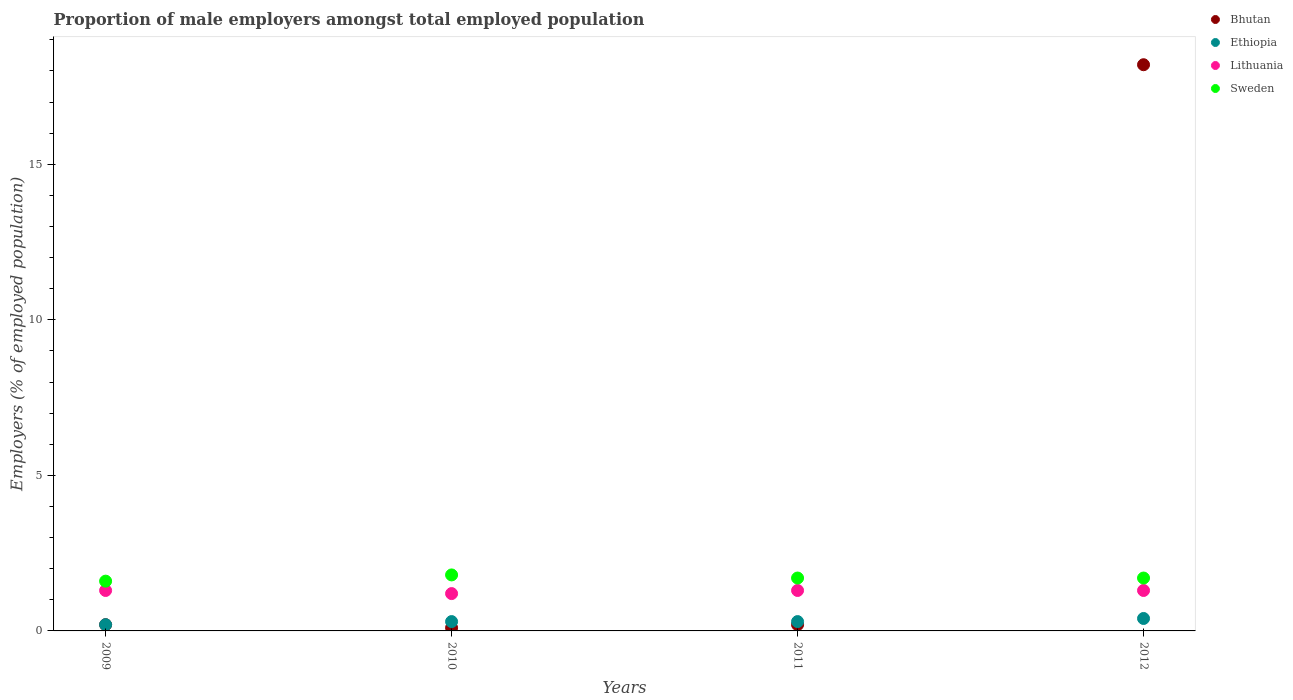How many different coloured dotlines are there?
Provide a succinct answer. 4. Is the number of dotlines equal to the number of legend labels?
Your response must be concise. Yes. What is the proportion of male employers in Ethiopia in 2011?
Ensure brevity in your answer.  0.3. Across all years, what is the maximum proportion of male employers in Ethiopia?
Your answer should be compact. 0.4. Across all years, what is the minimum proportion of male employers in Ethiopia?
Your answer should be very brief. 0.2. In which year was the proportion of male employers in Ethiopia maximum?
Make the answer very short. 2012. In which year was the proportion of male employers in Bhutan minimum?
Ensure brevity in your answer.  2010. What is the total proportion of male employers in Sweden in the graph?
Your answer should be compact. 6.8. What is the difference between the proportion of male employers in Bhutan in 2011 and that in 2012?
Offer a terse response. -18. What is the difference between the proportion of male employers in Lithuania in 2009 and the proportion of male employers in Bhutan in 2012?
Ensure brevity in your answer.  -16.9. What is the average proportion of male employers in Bhutan per year?
Your answer should be compact. 4.68. In the year 2011, what is the difference between the proportion of male employers in Ethiopia and proportion of male employers in Lithuania?
Your answer should be compact. -1. What is the ratio of the proportion of male employers in Bhutan in 2009 to that in 2012?
Make the answer very short. 0.01. Is the difference between the proportion of male employers in Ethiopia in 2009 and 2012 greater than the difference between the proportion of male employers in Lithuania in 2009 and 2012?
Ensure brevity in your answer.  No. What is the difference between the highest and the lowest proportion of male employers in Ethiopia?
Provide a short and direct response. 0.2. In how many years, is the proportion of male employers in Sweden greater than the average proportion of male employers in Sweden taken over all years?
Keep it short and to the point. 3. Is it the case that in every year, the sum of the proportion of male employers in Sweden and proportion of male employers in Lithuania  is greater than the sum of proportion of male employers in Bhutan and proportion of male employers in Ethiopia?
Make the answer very short. Yes. Is it the case that in every year, the sum of the proportion of male employers in Lithuania and proportion of male employers in Ethiopia  is greater than the proportion of male employers in Sweden?
Offer a terse response. No. How many dotlines are there?
Offer a very short reply. 4. What is the difference between two consecutive major ticks on the Y-axis?
Offer a terse response. 5. Are the values on the major ticks of Y-axis written in scientific E-notation?
Provide a succinct answer. No. Does the graph contain any zero values?
Offer a terse response. No. How many legend labels are there?
Provide a succinct answer. 4. What is the title of the graph?
Ensure brevity in your answer.  Proportion of male employers amongst total employed population. Does "Lebanon" appear as one of the legend labels in the graph?
Offer a very short reply. No. What is the label or title of the Y-axis?
Your answer should be very brief. Employers (% of employed population). What is the Employers (% of employed population) of Bhutan in 2009?
Offer a very short reply. 0.2. What is the Employers (% of employed population) in Ethiopia in 2009?
Keep it short and to the point. 0.2. What is the Employers (% of employed population) in Lithuania in 2009?
Give a very brief answer. 1.3. What is the Employers (% of employed population) in Sweden in 2009?
Provide a succinct answer. 1.6. What is the Employers (% of employed population) in Bhutan in 2010?
Your answer should be very brief. 0.1. What is the Employers (% of employed population) of Ethiopia in 2010?
Give a very brief answer. 0.3. What is the Employers (% of employed population) of Lithuania in 2010?
Offer a terse response. 1.2. What is the Employers (% of employed population) of Sweden in 2010?
Offer a very short reply. 1.8. What is the Employers (% of employed population) in Bhutan in 2011?
Provide a short and direct response. 0.2. What is the Employers (% of employed population) of Ethiopia in 2011?
Give a very brief answer. 0.3. What is the Employers (% of employed population) of Lithuania in 2011?
Keep it short and to the point. 1.3. What is the Employers (% of employed population) in Sweden in 2011?
Make the answer very short. 1.7. What is the Employers (% of employed population) of Bhutan in 2012?
Ensure brevity in your answer.  18.2. What is the Employers (% of employed population) of Ethiopia in 2012?
Your response must be concise. 0.4. What is the Employers (% of employed population) of Lithuania in 2012?
Ensure brevity in your answer.  1.3. What is the Employers (% of employed population) in Sweden in 2012?
Your answer should be very brief. 1.7. Across all years, what is the maximum Employers (% of employed population) of Bhutan?
Keep it short and to the point. 18.2. Across all years, what is the maximum Employers (% of employed population) of Ethiopia?
Your answer should be very brief. 0.4. Across all years, what is the maximum Employers (% of employed population) of Lithuania?
Give a very brief answer. 1.3. Across all years, what is the maximum Employers (% of employed population) in Sweden?
Offer a very short reply. 1.8. Across all years, what is the minimum Employers (% of employed population) in Bhutan?
Your answer should be compact. 0.1. Across all years, what is the minimum Employers (% of employed population) of Ethiopia?
Make the answer very short. 0.2. Across all years, what is the minimum Employers (% of employed population) of Lithuania?
Your answer should be very brief. 1.2. Across all years, what is the minimum Employers (% of employed population) in Sweden?
Ensure brevity in your answer.  1.6. What is the total Employers (% of employed population) in Bhutan in the graph?
Offer a terse response. 18.7. What is the difference between the Employers (% of employed population) of Ethiopia in 2009 and that in 2010?
Offer a terse response. -0.1. What is the difference between the Employers (% of employed population) in Sweden in 2009 and that in 2010?
Your response must be concise. -0.2. What is the difference between the Employers (% of employed population) of Bhutan in 2009 and that in 2011?
Your response must be concise. 0. What is the difference between the Employers (% of employed population) in Ethiopia in 2009 and that in 2012?
Offer a terse response. -0.2. What is the difference between the Employers (% of employed population) of Lithuania in 2009 and that in 2012?
Offer a terse response. 0. What is the difference between the Employers (% of employed population) in Bhutan in 2010 and that in 2011?
Provide a short and direct response. -0.1. What is the difference between the Employers (% of employed population) in Sweden in 2010 and that in 2011?
Ensure brevity in your answer.  0.1. What is the difference between the Employers (% of employed population) of Bhutan in 2010 and that in 2012?
Provide a short and direct response. -18.1. What is the difference between the Employers (% of employed population) of Ethiopia in 2010 and that in 2012?
Ensure brevity in your answer.  -0.1. What is the difference between the Employers (% of employed population) in Lithuania in 2010 and that in 2012?
Make the answer very short. -0.1. What is the difference between the Employers (% of employed population) in Ethiopia in 2011 and that in 2012?
Make the answer very short. -0.1. What is the difference between the Employers (% of employed population) of Sweden in 2011 and that in 2012?
Ensure brevity in your answer.  0. What is the difference between the Employers (% of employed population) in Bhutan in 2009 and the Employers (% of employed population) in Ethiopia in 2010?
Your response must be concise. -0.1. What is the difference between the Employers (% of employed population) in Ethiopia in 2009 and the Employers (% of employed population) in Sweden in 2010?
Your response must be concise. -1.6. What is the difference between the Employers (% of employed population) in Bhutan in 2009 and the Employers (% of employed population) in Sweden in 2011?
Provide a succinct answer. -1.5. What is the difference between the Employers (% of employed population) in Lithuania in 2009 and the Employers (% of employed population) in Sweden in 2011?
Your response must be concise. -0.4. What is the difference between the Employers (% of employed population) in Bhutan in 2009 and the Employers (% of employed population) in Sweden in 2012?
Your answer should be very brief. -1.5. What is the difference between the Employers (% of employed population) of Ethiopia in 2009 and the Employers (% of employed population) of Lithuania in 2012?
Your answer should be compact. -1.1. What is the difference between the Employers (% of employed population) in Ethiopia in 2009 and the Employers (% of employed population) in Sweden in 2012?
Offer a very short reply. -1.5. What is the difference between the Employers (% of employed population) of Bhutan in 2010 and the Employers (% of employed population) of Ethiopia in 2011?
Offer a very short reply. -0.2. What is the difference between the Employers (% of employed population) of Bhutan in 2010 and the Employers (% of employed population) of Sweden in 2011?
Offer a terse response. -1.6. What is the difference between the Employers (% of employed population) of Ethiopia in 2010 and the Employers (% of employed population) of Sweden in 2011?
Provide a succinct answer. -1.4. What is the difference between the Employers (% of employed population) in Lithuania in 2010 and the Employers (% of employed population) in Sweden in 2011?
Give a very brief answer. -0.5. What is the difference between the Employers (% of employed population) of Bhutan in 2010 and the Employers (% of employed population) of Ethiopia in 2012?
Offer a very short reply. -0.3. What is the difference between the Employers (% of employed population) in Bhutan in 2010 and the Employers (% of employed population) in Lithuania in 2012?
Offer a terse response. -1.2. What is the difference between the Employers (% of employed population) of Bhutan in 2010 and the Employers (% of employed population) of Sweden in 2012?
Ensure brevity in your answer.  -1.6. What is the difference between the Employers (% of employed population) in Ethiopia in 2010 and the Employers (% of employed population) in Sweden in 2012?
Keep it short and to the point. -1.4. What is the difference between the Employers (% of employed population) of Lithuania in 2010 and the Employers (% of employed population) of Sweden in 2012?
Give a very brief answer. -0.5. What is the difference between the Employers (% of employed population) of Bhutan in 2011 and the Employers (% of employed population) of Ethiopia in 2012?
Give a very brief answer. -0.2. What is the difference between the Employers (% of employed population) of Bhutan in 2011 and the Employers (% of employed population) of Lithuania in 2012?
Provide a short and direct response. -1.1. What is the difference between the Employers (% of employed population) of Lithuania in 2011 and the Employers (% of employed population) of Sweden in 2012?
Your answer should be compact. -0.4. What is the average Employers (% of employed population) of Bhutan per year?
Your response must be concise. 4.67. What is the average Employers (% of employed population) of Ethiopia per year?
Offer a very short reply. 0.3. What is the average Employers (% of employed population) of Lithuania per year?
Your answer should be very brief. 1.27. What is the average Employers (% of employed population) in Sweden per year?
Ensure brevity in your answer.  1.7. In the year 2009, what is the difference between the Employers (% of employed population) of Bhutan and Employers (% of employed population) of Lithuania?
Your answer should be compact. -1.1. In the year 2009, what is the difference between the Employers (% of employed population) of Ethiopia and Employers (% of employed population) of Lithuania?
Keep it short and to the point. -1.1. In the year 2009, what is the difference between the Employers (% of employed population) of Lithuania and Employers (% of employed population) of Sweden?
Make the answer very short. -0.3. In the year 2010, what is the difference between the Employers (% of employed population) in Bhutan and Employers (% of employed population) in Ethiopia?
Ensure brevity in your answer.  -0.2. In the year 2010, what is the difference between the Employers (% of employed population) of Bhutan and Employers (% of employed population) of Lithuania?
Your answer should be very brief. -1.1. In the year 2010, what is the difference between the Employers (% of employed population) in Ethiopia and Employers (% of employed population) in Sweden?
Offer a very short reply. -1.5. In the year 2010, what is the difference between the Employers (% of employed population) of Lithuania and Employers (% of employed population) of Sweden?
Make the answer very short. -0.6. In the year 2011, what is the difference between the Employers (% of employed population) of Bhutan and Employers (% of employed population) of Ethiopia?
Provide a short and direct response. -0.1. In the year 2011, what is the difference between the Employers (% of employed population) in Bhutan and Employers (% of employed population) in Lithuania?
Your answer should be very brief. -1.1. In the year 2011, what is the difference between the Employers (% of employed population) of Bhutan and Employers (% of employed population) of Sweden?
Provide a succinct answer. -1.5. In the year 2012, what is the difference between the Employers (% of employed population) of Bhutan and Employers (% of employed population) of Ethiopia?
Your response must be concise. 17.8. In the year 2012, what is the difference between the Employers (% of employed population) of Bhutan and Employers (% of employed population) of Lithuania?
Keep it short and to the point. 16.9. In the year 2012, what is the difference between the Employers (% of employed population) in Bhutan and Employers (% of employed population) in Sweden?
Keep it short and to the point. 16.5. In the year 2012, what is the difference between the Employers (% of employed population) of Ethiopia and Employers (% of employed population) of Lithuania?
Ensure brevity in your answer.  -0.9. In the year 2012, what is the difference between the Employers (% of employed population) in Lithuania and Employers (% of employed population) in Sweden?
Give a very brief answer. -0.4. What is the ratio of the Employers (% of employed population) in Ethiopia in 2009 to that in 2010?
Provide a succinct answer. 0.67. What is the ratio of the Employers (% of employed population) of Bhutan in 2009 to that in 2011?
Provide a succinct answer. 1. What is the ratio of the Employers (% of employed population) in Ethiopia in 2009 to that in 2011?
Offer a very short reply. 0.67. What is the ratio of the Employers (% of employed population) of Sweden in 2009 to that in 2011?
Ensure brevity in your answer.  0.94. What is the ratio of the Employers (% of employed population) of Bhutan in 2009 to that in 2012?
Make the answer very short. 0.01. What is the ratio of the Employers (% of employed population) of Ethiopia in 2009 to that in 2012?
Your response must be concise. 0.5. What is the ratio of the Employers (% of employed population) of Bhutan in 2010 to that in 2011?
Provide a succinct answer. 0.5. What is the ratio of the Employers (% of employed population) of Sweden in 2010 to that in 2011?
Your answer should be very brief. 1.06. What is the ratio of the Employers (% of employed population) of Bhutan in 2010 to that in 2012?
Offer a very short reply. 0.01. What is the ratio of the Employers (% of employed population) of Sweden in 2010 to that in 2012?
Offer a terse response. 1.06. What is the ratio of the Employers (% of employed population) of Bhutan in 2011 to that in 2012?
Make the answer very short. 0.01. What is the ratio of the Employers (% of employed population) of Lithuania in 2011 to that in 2012?
Offer a very short reply. 1. What is the ratio of the Employers (% of employed population) in Sweden in 2011 to that in 2012?
Give a very brief answer. 1. What is the difference between the highest and the second highest Employers (% of employed population) in Ethiopia?
Your answer should be compact. 0.1. What is the difference between the highest and the second highest Employers (% of employed population) of Lithuania?
Offer a terse response. 0. What is the difference between the highest and the second highest Employers (% of employed population) of Sweden?
Your answer should be very brief. 0.1. 